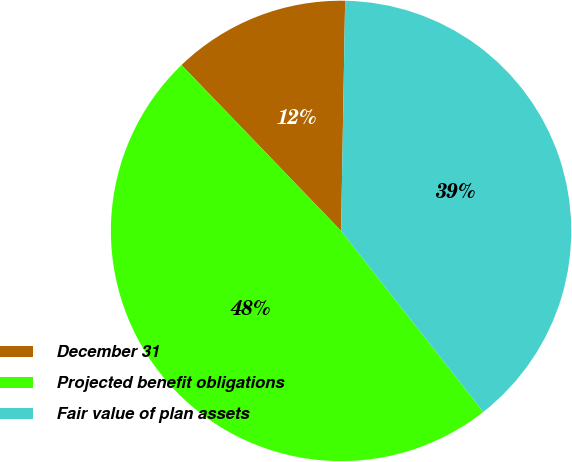<chart> <loc_0><loc_0><loc_500><loc_500><pie_chart><fcel>December 31<fcel>Projected benefit obligations<fcel>Fair value of plan assets<nl><fcel>12.47%<fcel>48.41%<fcel>39.12%<nl></chart> 